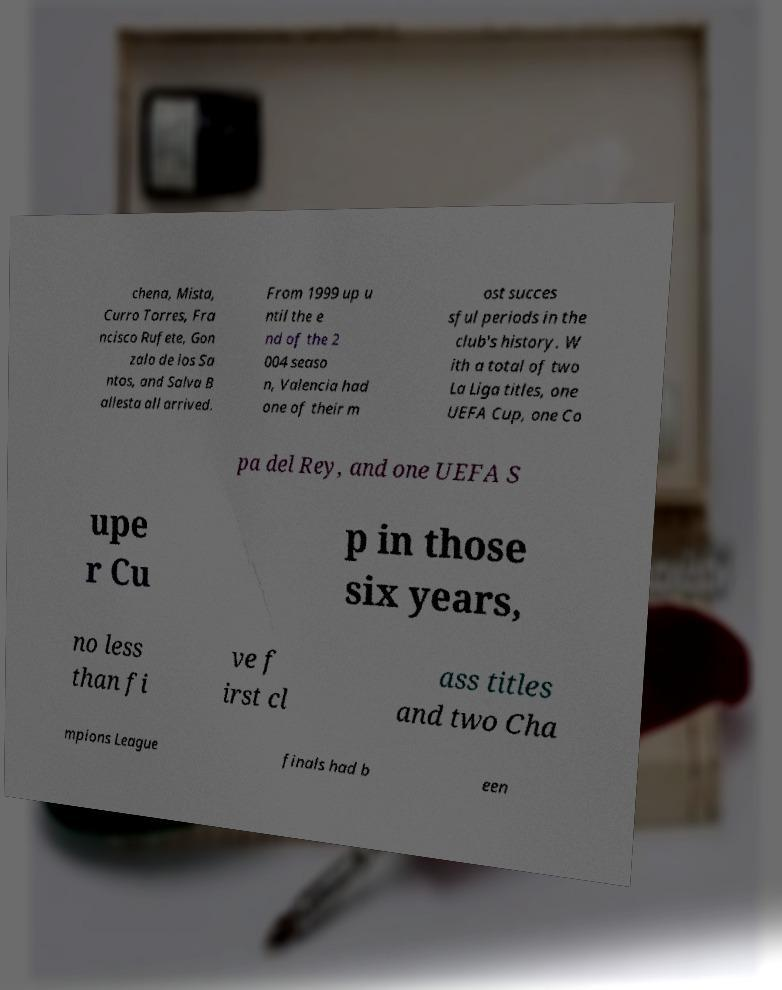I need the written content from this picture converted into text. Can you do that? chena, Mista, Curro Torres, Fra ncisco Rufete, Gon zalo de los Sa ntos, and Salva B allesta all arrived. From 1999 up u ntil the e nd of the 2 004 seaso n, Valencia had one of their m ost succes sful periods in the club's history. W ith a total of two La Liga titles, one UEFA Cup, one Co pa del Rey, and one UEFA S upe r Cu p in those six years, no less than fi ve f irst cl ass titles and two Cha mpions League finals had b een 